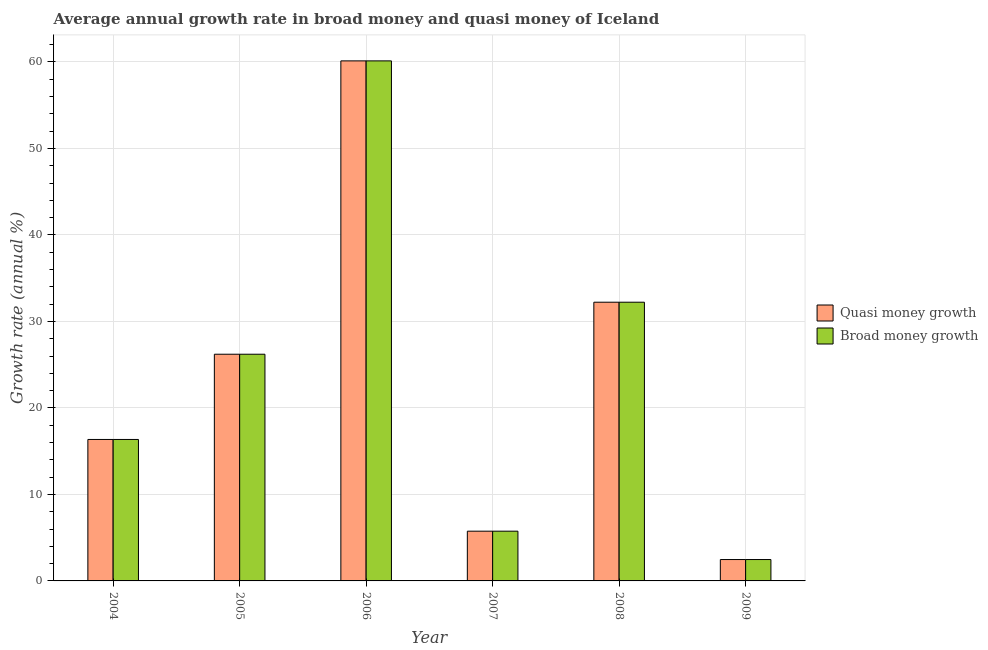How many groups of bars are there?
Give a very brief answer. 6. Are the number of bars on each tick of the X-axis equal?
Provide a succinct answer. Yes. How many bars are there on the 4th tick from the left?
Make the answer very short. 2. What is the annual growth rate in broad money in 2006?
Keep it short and to the point. 60.12. Across all years, what is the maximum annual growth rate in quasi money?
Offer a very short reply. 60.12. Across all years, what is the minimum annual growth rate in quasi money?
Give a very brief answer. 2.47. What is the total annual growth rate in quasi money in the graph?
Provide a succinct answer. 143.12. What is the difference between the annual growth rate in quasi money in 2006 and that in 2009?
Your response must be concise. 57.65. What is the difference between the annual growth rate in broad money in 2005 and the annual growth rate in quasi money in 2008?
Ensure brevity in your answer.  -6.01. What is the average annual growth rate in quasi money per year?
Offer a terse response. 23.85. What is the ratio of the annual growth rate in quasi money in 2005 to that in 2008?
Give a very brief answer. 0.81. What is the difference between the highest and the second highest annual growth rate in quasi money?
Offer a very short reply. 27.9. What is the difference between the highest and the lowest annual growth rate in broad money?
Provide a short and direct response. 57.65. Is the sum of the annual growth rate in quasi money in 2006 and 2008 greater than the maximum annual growth rate in broad money across all years?
Ensure brevity in your answer.  Yes. What does the 1st bar from the left in 2009 represents?
Give a very brief answer. Quasi money growth. What does the 2nd bar from the right in 2007 represents?
Ensure brevity in your answer.  Quasi money growth. What is the difference between two consecutive major ticks on the Y-axis?
Your answer should be compact. 10. Are the values on the major ticks of Y-axis written in scientific E-notation?
Provide a succinct answer. No. Does the graph contain any zero values?
Ensure brevity in your answer.  No. How many legend labels are there?
Your response must be concise. 2. How are the legend labels stacked?
Provide a succinct answer. Vertical. What is the title of the graph?
Offer a terse response. Average annual growth rate in broad money and quasi money of Iceland. Does "Nonresident" appear as one of the legend labels in the graph?
Your response must be concise. No. What is the label or title of the X-axis?
Keep it short and to the point. Year. What is the label or title of the Y-axis?
Offer a very short reply. Growth rate (annual %). What is the Growth rate (annual %) in Quasi money growth in 2004?
Your response must be concise. 16.35. What is the Growth rate (annual %) in Broad money growth in 2004?
Your answer should be compact. 16.35. What is the Growth rate (annual %) of Quasi money growth in 2005?
Keep it short and to the point. 26.21. What is the Growth rate (annual %) of Broad money growth in 2005?
Offer a very short reply. 26.21. What is the Growth rate (annual %) of Quasi money growth in 2006?
Keep it short and to the point. 60.12. What is the Growth rate (annual %) in Broad money growth in 2006?
Keep it short and to the point. 60.12. What is the Growth rate (annual %) in Quasi money growth in 2007?
Make the answer very short. 5.75. What is the Growth rate (annual %) in Broad money growth in 2007?
Give a very brief answer. 5.75. What is the Growth rate (annual %) of Quasi money growth in 2008?
Provide a succinct answer. 32.22. What is the Growth rate (annual %) in Broad money growth in 2008?
Make the answer very short. 32.22. What is the Growth rate (annual %) in Quasi money growth in 2009?
Your response must be concise. 2.47. What is the Growth rate (annual %) in Broad money growth in 2009?
Offer a terse response. 2.47. Across all years, what is the maximum Growth rate (annual %) in Quasi money growth?
Your response must be concise. 60.12. Across all years, what is the maximum Growth rate (annual %) of Broad money growth?
Give a very brief answer. 60.12. Across all years, what is the minimum Growth rate (annual %) of Quasi money growth?
Your answer should be very brief. 2.47. Across all years, what is the minimum Growth rate (annual %) in Broad money growth?
Your answer should be very brief. 2.47. What is the total Growth rate (annual %) in Quasi money growth in the graph?
Give a very brief answer. 143.12. What is the total Growth rate (annual %) in Broad money growth in the graph?
Provide a succinct answer. 143.12. What is the difference between the Growth rate (annual %) in Quasi money growth in 2004 and that in 2005?
Your answer should be very brief. -9.85. What is the difference between the Growth rate (annual %) in Broad money growth in 2004 and that in 2005?
Offer a very short reply. -9.85. What is the difference between the Growth rate (annual %) of Quasi money growth in 2004 and that in 2006?
Ensure brevity in your answer.  -43.77. What is the difference between the Growth rate (annual %) of Broad money growth in 2004 and that in 2006?
Your answer should be compact. -43.77. What is the difference between the Growth rate (annual %) of Quasi money growth in 2004 and that in 2007?
Your response must be concise. 10.6. What is the difference between the Growth rate (annual %) in Broad money growth in 2004 and that in 2007?
Provide a short and direct response. 10.6. What is the difference between the Growth rate (annual %) in Quasi money growth in 2004 and that in 2008?
Provide a short and direct response. -15.87. What is the difference between the Growth rate (annual %) of Broad money growth in 2004 and that in 2008?
Offer a very short reply. -15.87. What is the difference between the Growth rate (annual %) of Quasi money growth in 2004 and that in 2009?
Your response must be concise. 13.88. What is the difference between the Growth rate (annual %) in Broad money growth in 2004 and that in 2009?
Your response must be concise. 13.88. What is the difference between the Growth rate (annual %) of Quasi money growth in 2005 and that in 2006?
Your answer should be very brief. -33.91. What is the difference between the Growth rate (annual %) in Broad money growth in 2005 and that in 2006?
Your answer should be very brief. -33.91. What is the difference between the Growth rate (annual %) in Quasi money growth in 2005 and that in 2007?
Provide a succinct answer. 20.46. What is the difference between the Growth rate (annual %) of Broad money growth in 2005 and that in 2007?
Your answer should be very brief. 20.46. What is the difference between the Growth rate (annual %) in Quasi money growth in 2005 and that in 2008?
Keep it short and to the point. -6.01. What is the difference between the Growth rate (annual %) in Broad money growth in 2005 and that in 2008?
Provide a short and direct response. -6.01. What is the difference between the Growth rate (annual %) in Quasi money growth in 2005 and that in 2009?
Provide a short and direct response. 23.74. What is the difference between the Growth rate (annual %) of Broad money growth in 2005 and that in 2009?
Provide a short and direct response. 23.74. What is the difference between the Growth rate (annual %) in Quasi money growth in 2006 and that in 2007?
Provide a succinct answer. 54.37. What is the difference between the Growth rate (annual %) of Broad money growth in 2006 and that in 2007?
Make the answer very short. 54.37. What is the difference between the Growth rate (annual %) in Quasi money growth in 2006 and that in 2008?
Provide a succinct answer. 27.9. What is the difference between the Growth rate (annual %) in Broad money growth in 2006 and that in 2008?
Make the answer very short. 27.9. What is the difference between the Growth rate (annual %) in Quasi money growth in 2006 and that in 2009?
Offer a terse response. 57.65. What is the difference between the Growth rate (annual %) of Broad money growth in 2006 and that in 2009?
Keep it short and to the point. 57.65. What is the difference between the Growth rate (annual %) of Quasi money growth in 2007 and that in 2008?
Make the answer very short. -26.47. What is the difference between the Growth rate (annual %) in Broad money growth in 2007 and that in 2008?
Provide a short and direct response. -26.47. What is the difference between the Growth rate (annual %) in Quasi money growth in 2007 and that in 2009?
Provide a short and direct response. 3.28. What is the difference between the Growth rate (annual %) of Broad money growth in 2007 and that in 2009?
Your answer should be very brief. 3.28. What is the difference between the Growth rate (annual %) of Quasi money growth in 2008 and that in 2009?
Your answer should be very brief. 29.75. What is the difference between the Growth rate (annual %) in Broad money growth in 2008 and that in 2009?
Ensure brevity in your answer.  29.75. What is the difference between the Growth rate (annual %) of Quasi money growth in 2004 and the Growth rate (annual %) of Broad money growth in 2005?
Your answer should be compact. -9.85. What is the difference between the Growth rate (annual %) in Quasi money growth in 2004 and the Growth rate (annual %) in Broad money growth in 2006?
Your answer should be compact. -43.77. What is the difference between the Growth rate (annual %) of Quasi money growth in 2004 and the Growth rate (annual %) of Broad money growth in 2007?
Provide a succinct answer. 10.6. What is the difference between the Growth rate (annual %) in Quasi money growth in 2004 and the Growth rate (annual %) in Broad money growth in 2008?
Offer a terse response. -15.87. What is the difference between the Growth rate (annual %) of Quasi money growth in 2004 and the Growth rate (annual %) of Broad money growth in 2009?
Your answer should be compact. 13.88. What is the difference between the Growth rate (annual %) of Quasi money growth in 2005 and the Growth rate (annual %) of Broad money growth in 2006?
Provide a short and direct response. -33.91. What is the difference between the Growth rate (annual %) of Quasi money growth in 2005 and the Growth rate (annual %) of Broad money growth in 2007?
Keep it short and to the point. 20.46. What is the difference between the Growth rate (annual %) in Quasi money growth in 2005 and the Growth rate (annual %) in Broad money growth in 2008?
Provide a short and direct response. -6.01. What is the difference between the Growth rate (annual %) of Quasi money growth in 2005 and the Growth rate (annual %) of Broad money growth in 2009?
Provide a succinct answer. 23.74. What is the difference between the Growth rate (annual %) in Quasi money growth in 2006 and the Growth rate (annual %) in Broad money growth in 2007?
Your answer should be compact. 54.37. What is the difference between the Growth rate (annual %) of Quasi money growth in 2006 and the Growth rate (annual %) of Broad money growth in 2008?
Provide a succinct answer. 27.9. What is the difference between the Growth rate (annual %) of Quasi money growth in 2006 and the Growth rate (annual %) of Broad money growth in 2009?
Your answer should be compact. 57.65. What is the difference between the Growth rate (annual %) in Quasi money growth in 2007 and the Growth rate (annual %) in Broad money growth in 2008?
Give a very brief answer. -26.47. What is the difference between the Growth rate (annual %) of Quasi money growth in 2007 and the Growth rate (annual %) of Broad money growth in 2009?
Your answer should be compact. 3.28. What is the difference between the Growth rate (annual %) in Quasi money growth in 2008 and the Growth rate (annual %) in Broad money growth in 2009?
Provide a succinct answer. 29.75. What is the average Growth rate (annual %) in Quasi money growth per year?
Provide a short and direct response. 23.85. What is the average Growth rate (annual %) of Broad money growth per year?
Your response must be concise. 23.85. In the year 2004, what is the difference between the Growth rate (annual %) of Quasi money growth and Growth rate (annual %) of Broad money growth?
Your response must be concise. 0. In the year 2007, what is the difference between the Growth rate (annual %) in Quasi money growth and Growth rate (annual %) in Broad money growth?
Your answer should be very brief. 0. In the year 2008, what is the difference between the Growth rate (annual %) of Quasi money growth and Growth rate (annual %) of Broad money growth?
Offer a terse response. 0. What is the ratio of the Growth rate (annual %) in Quasi money growth in 2004 to that in 2005?
Offer a terse response. 0.62. What is the ratio of the Growth rate (annual %) of Broad money growth in 2004 to that in 2005?
Offer a terse response. 0.62. What is the ratio of the Growth rate (annual %) in Quasi money growth in 2004 to that in 2006?
Keep it short and to the point. 0.27. What is the ratio of the Growth rate (annual %) of Broad money growth in 2004 to that in 2006?
Your answer should be compact. 0.27. What is the ratio of the Growth rate (annual %) in Quasi money growth in 2004 to that in 2007?
Offer a very short reply. 2.84. What is the ratio of the Growth rate (annual %) in Broad money growth in 2004 to that in 2007?
Make the answer very short. 2.84. What is the ratio of the Growth rate (annual %) of Quasi money growth in 2004 to that in 2008?
Your response must be concise. 0.51. What is the ratio of the Growth rate (annual %) of Broad money growth in 2004 to that in 2008?
Give a very brief answer. 0.51. What is the ratio of the Growth rate (annual %) of Quasi money growth in 2004 to that in 2009?
Offer a terse response. 6.62. What is the ratio of the Growth rate (annual %) in Broad money growth in 2004 to that in 2009?
Your response must be concise. 6.62. What is the ratio of the Growth rate (annual %) of Quasi money growth in 2005 to that in 2006?
Ensure brevity in your answer.  0.44. What is the ratio of the Growth rate (annual %) in Broad money growth in 2005 to that in 2006?
Offer a terse response. 0.44. What is the ratio of the Growth rate (annual %) in Quasi money growth in 2005 to that in 2007?
Make the answer very short. 4.56. What is the ratio of the Growth rate (annual %) of Broad money growth in 2005 to that in 2007?
Provide a succinct answer. 4.56. What is the ratio of the Growth rate (annual %) of Quasi money growth in 2005 to that in 2008?
Give a very brief answer. 0.81. What is the ratio of the Growth rate (annual %) of Broad money growth in 2005 to that in 2008?
Your answer should be very brief. 0.81. What is the ratio of the Growth rate (annual %) of Quasi money growth in 2005 to that in 2009?
Keep it short and to the point. 10.61. What is the ratio of the Growth rate (annual %) of Broad money growth in 2005 to that in 2009?
Ensure brevity in your answer.  10.61. What is the ratio of the Growth rate (annual %) in Quasi money growth in 2006 to that in 2007?
Provide a succinct answer. 10.45. What is the ratio of the Growth rate (annual %) in Broad money growth in 2006 to that in 2007?
Give a very brief answer. 10.45. What is the ratio of the Growth rate (annual %) of Quasi money growth in 2006 to that in 2008?
Provide a succinct answer. 1.87. What is the ratio of the Growth rate (annual %) in Broad money growth in 2006 to that in 2008?
Your answer should be compact. 1.87. What is the ratio of the Growth rate (annual %) of Quasi money growth in 2006 to that in 2009?
Your response must be concise. 24.33. What is the ratio of the Growth rate (annual %) of Broad money growth in 2006 to that in 2009?
Offer a very short reply. 24.33. What is the ratio of the Growth rate (annual %) in Quasi money growth in 2007 to that in 2008?
Offer a very short reply. 0.18. What is the ratio of the Growth rate (annual %) in Broad money growth in 2007 to that in 2008?
Your response must be concise. 0.18. What is the ratio of the Growth rate (annual %) of Quasi money growth in 2007 to that in 2009?
Ensure brevity in your answer.  2.33. What is the ratio of the Growth rate (annual %) of Broad money growth in 2007 to that in 2009?
Provide a succinct answer. 2.33. What is the ratio of the Growth rate (annual %) in Quasi money growth in 2008 to that in 2009?
Your answer should be very brief. 13.04. What is the ratio of the Growth rate (annual %) of Broad money growth in 2008 to that in 2009?
Ensure brevity in your answer.  13.04. What is the difference between the highest and the second highest Growth rate (annual %) in Quasi money growth?
Ensure brevity in your answer.  27.9. What is the difference between the highest and the second highest Growth rate (annual %) of Broad money growth?
Make the answer very short. 27.9. What is the difference between the highest and the lowest Growth rate (annual %) of Quasi money growth?
Give a very brief answer. 57.65. What is the difference between the highest and the lowest Growth rate (annual %) in Broad money growth?
Offer a terse response. 57.65. 